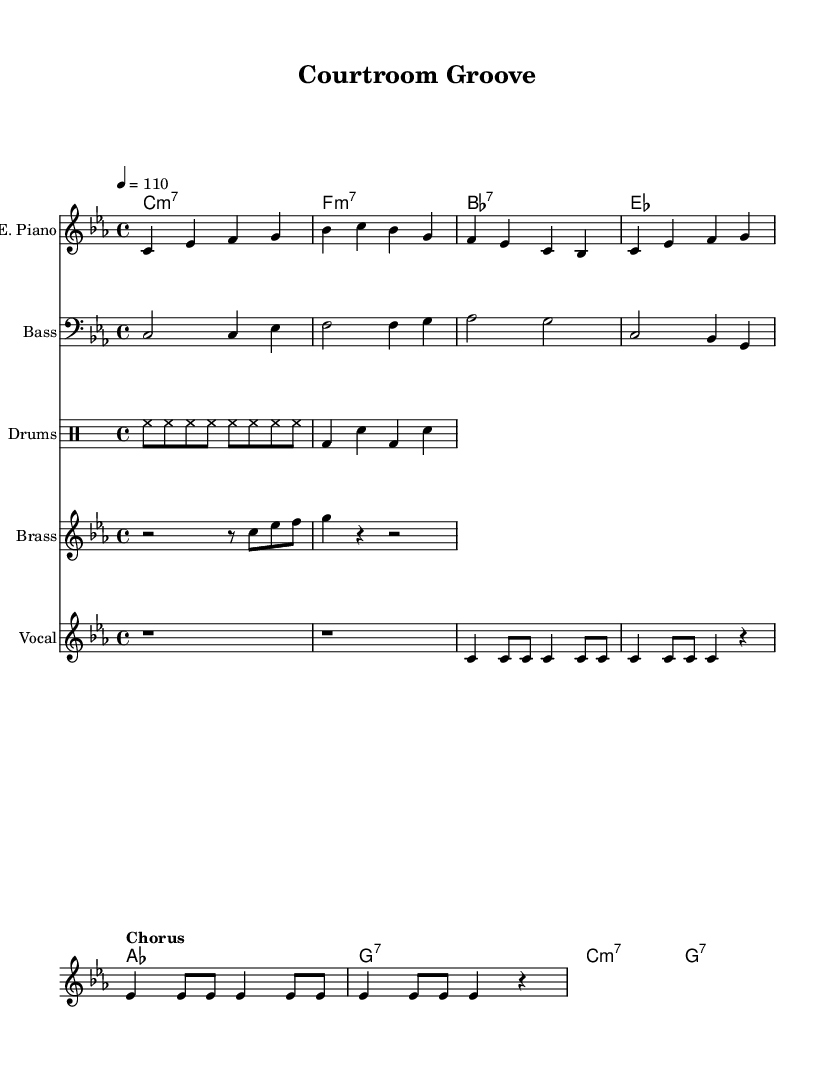What is the key signature of this music? The key signature is C minor, as indicated by the presence of three flats (B flat, E flat, and A flat) typically associated with the key signature of C minor.
Answer: C minor What is the time signature of this music? The time signature is four-four, represented as 4/4 at the beginning of the piece, indicating that there are four beats in each measure and the quarter note receives one beat.
Answer: 4/4 What is the tempo marking for this music? The tempo marking is indicating a speed of 110 beats per minute, which reflects the intended movement of the music.
Answer: 110 How many measures are in the vocal part? By counting the measures in the vocal staff, there are eight measures, as seen from the notated music in that staff.
Answer: 8 What is the main theme of the chorus lyrics? The main theme is about bridging the gap through music, reflecting a message of connection and unity using a groove.
Answer: Bridgin' the gap What instruments are used in this piece? This piece includes electric piano, bass, drums, brass (trumpet/sax), and vocals, as indicated by the different staves labeled for each instrument.
Answer: Electric piano, bass, drums, trumpet/sax, vocals What type of chord is used at the beginning of the piece? The chord used at the beginning is a C minor seventh chord, as indicated by the chord names section and how it appears in the first measure.
Answer: C minor seventh 